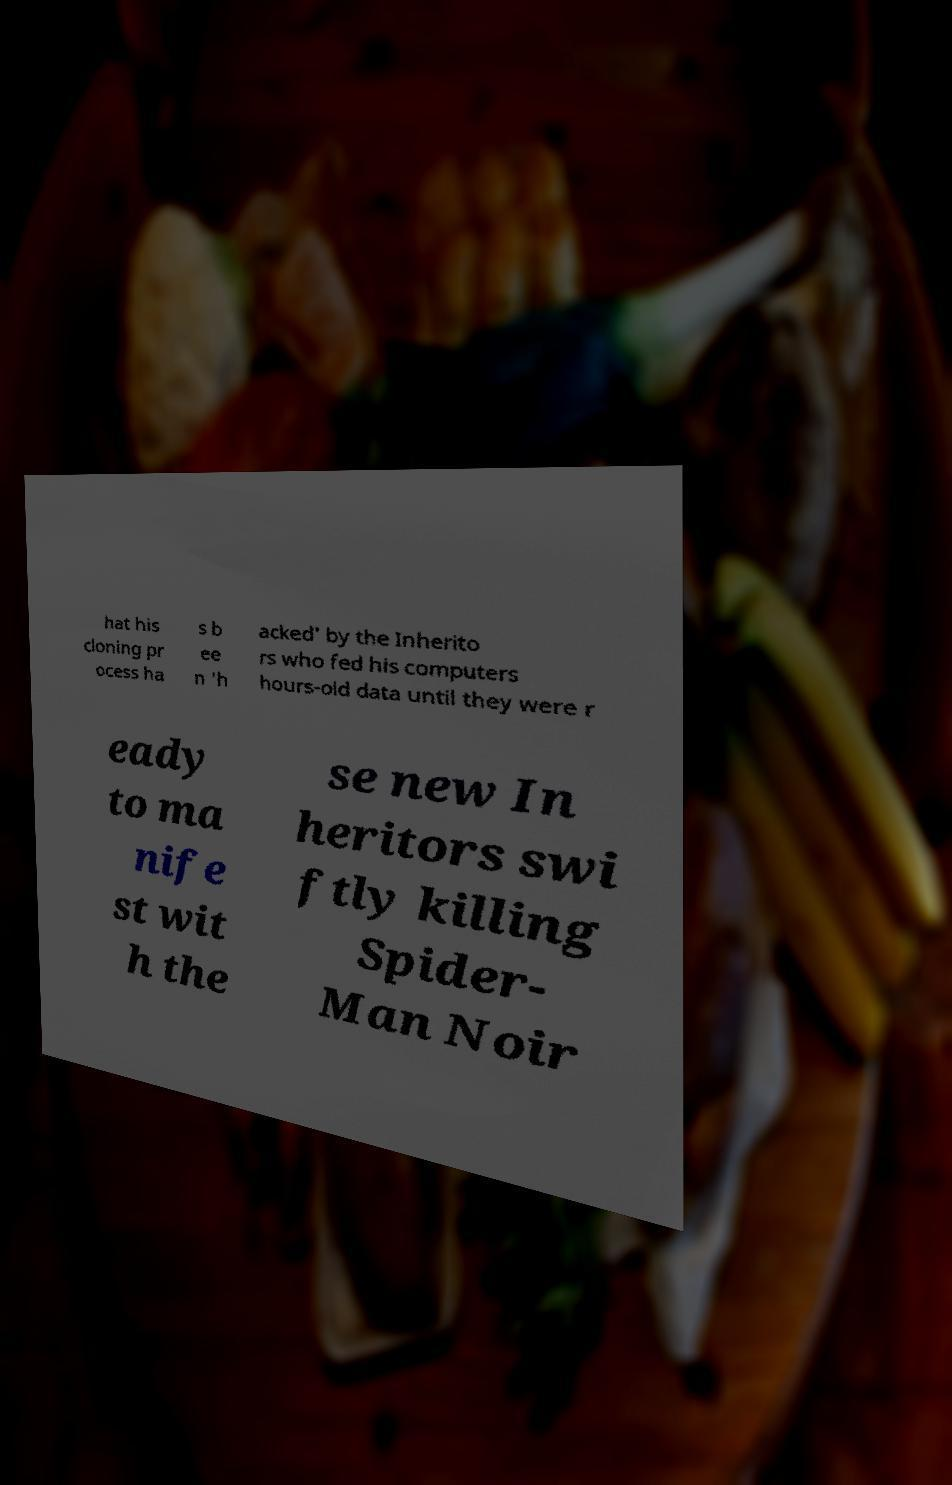What messages or text are displayed in this image? I need them in a readable, typed format. hat his cloning pr ocess ha s b ee n 'h acked' by the Inherito rs who fed his computers hours-old data until they were r eady to ma nife st wit h the se new In heritors swi ftly killing Spider- Man Noir 